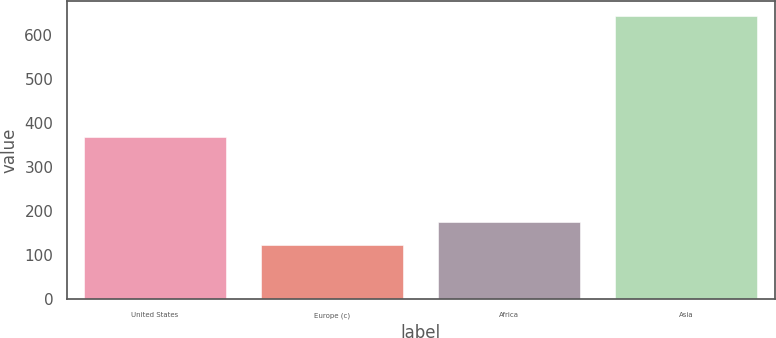Convert chart. <chart><loc_0><loc_0><loc_500><loc_500><bar_chart><fcel>United States<fcel>Europe (c)<fcel>Africa<fcel>Asia<nl><fcel>368<fcel>123<fcel>175<fcel>643<nl></chart> 